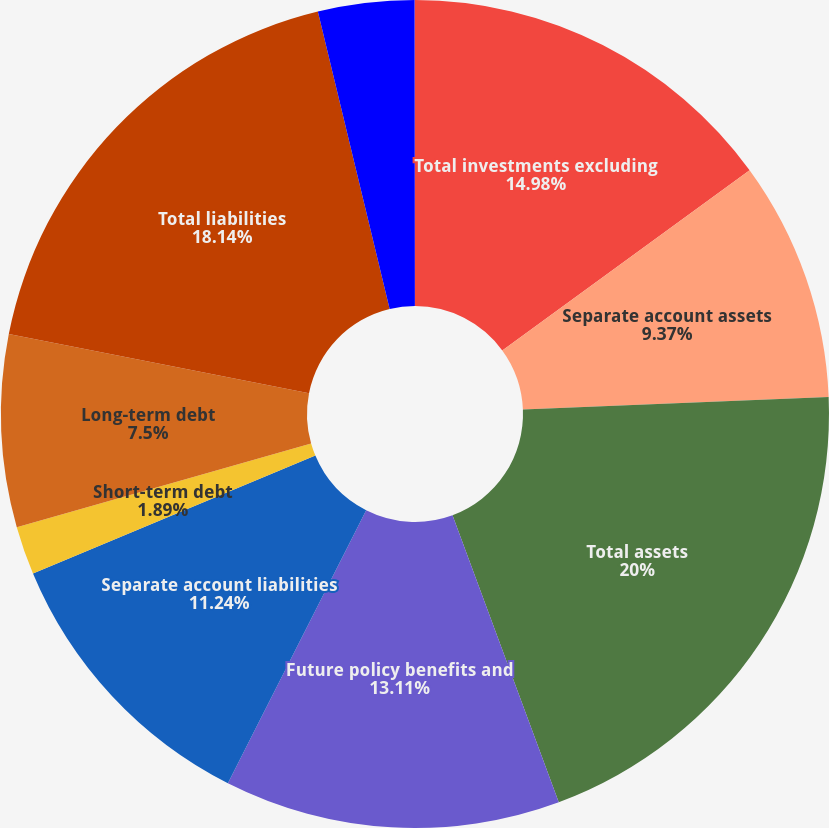<chart> <loc_0><loc_0><loc_500><loc_500><pie_chart><fcel>Total investments excluding<fcel>Separate account assets<fcel>Total assets<fcel>Future policy benefits and<fcel>Separate account liabilities<fcel>Short-term debt<fcel>Long-term debt<fcel>Total liabilities<fcel>Prudential Financial Inc<fcel>Noncontrolling interests<nl><fcel>14.98%<fcel>9.37%<fcel>20.01%<fcel>13.11%<fcel>11.24%<fcel>1.89%<fcel>7.5%<fcel>18.14%<fcel>3.76%<fcel>0.01%<nl></chart> 